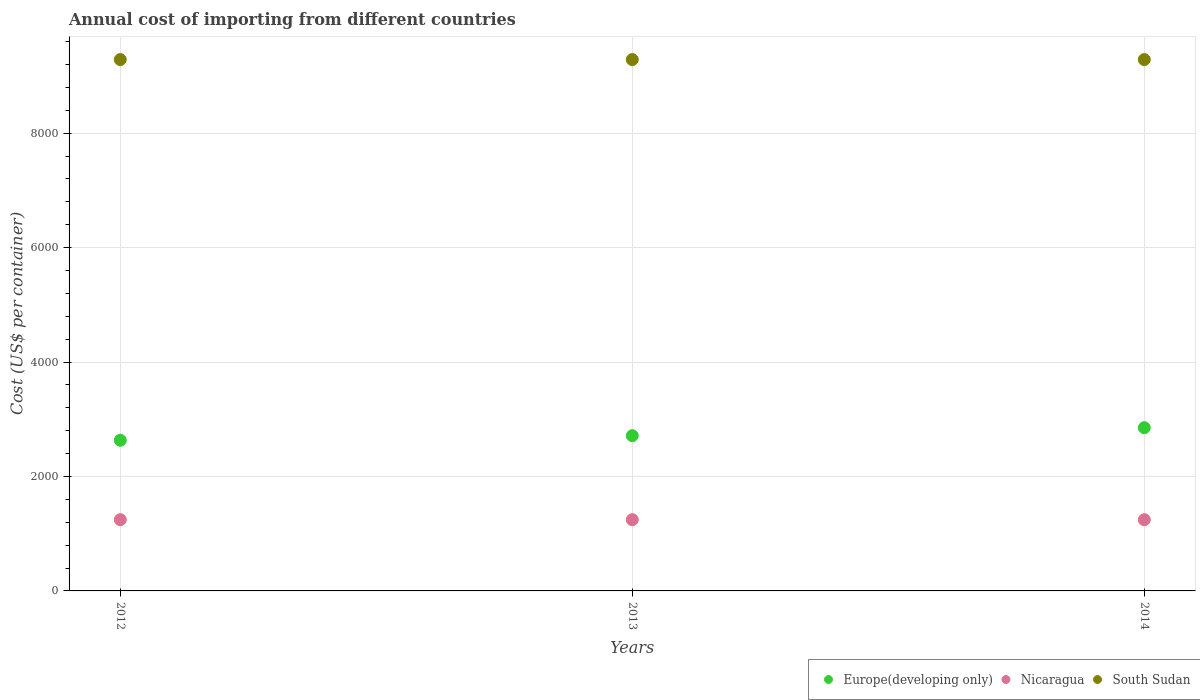How many different coloured dotlines are there?
Offer a terse response. 3. Is the number of dotlines equal to the number of legend labels?
Ensure brevity in your answer.  Yes. What is the total annual cost of importing in Europe(developing only) in 2013?
Ensure brevity in your answer.  2713. Across all years, what is the maximum total annual cost of importing in Nicaragua?
Your answer should be compact. 1245. Across all years, what is the minimum total annual cost of importing in Europe(developing only)?
Your answer should be compact. 2632.79. In which year was the total annual cost of importing in Europe(developing only) minimum?
Keep it short and to the point. 2012. What is the total total annual cost of importing in South Sudan in the graph?
Give a very brief answer. 2.79e+04. What is the difference between the total annual cost of importing in South Sudan in 2012 and that in 2014?
Give a very brief answer. 0. What is the difference between the total annual cost of importing in Nicaragua in 2013 and the total annual cost of importing in Europe(developing only) in 2012?
Offer a terse response. -1387.79. What is the average total annual cost of importing in Europe(developing only) per year?
Offer a very short reply. 2732.93. In the year 2014, what is the difference between the total annual cost of importing in South Sudan and total annual cost of importing in Nicaragua?
Offer a terse response. 8040. What is the ratio of the total annual cost of importing in Nicaragua in 2012 to that in 2013?
Your response must be concise. 1. Is the difference between the total annual cost of importing in South Sudan in 2012 and 2014 greater than the difference between the total annual cost of importing in Nicaragua in 2012 and 2014?
Make the answer very short. No. What is the difference between the highest and the second highest total annual cost of importing in Europe(developing only)?
Keep it short and to the point. 140. What is the difference between the highest and the lowest total annual cost of importing in Europe(developing only)?
Provide a succinct answer. 220.21. In how many years, is the total annual cost of importing in Nicaragua greater than the average total annual cost of importing in Nicaragua taken over all years?
Keep it short and to the point. 0. Is it the case that in every year, the sum of the total annual cost of importing in South Sudan and total annual cost of importing in Nicaragua  is greater than the total annual cost of importing in Europe(developing only)?
Make the answer very short. Yes. Does the total annual cost of importing in Europe(developing only) monotonically increase over the years?
Keep it short and to the point. Yes. Is the total annual cost of importing in Europe(developing only) strictly greater than the total annual cost of importing in South Sudan over the years?
Provide a succinct answer. No. Does the graph contain grids?
Your response must be concise. Yes. What is the title of the graph?
Offer a very short reply. Annual cost of importing from different countries. Does "South Asia" appear as one of the legend labels in the graph?
Make the answer very short. No. What is the label or title of the Y-axis?
Offer a very short reply. Cost (US$ per container). What is the Cost (US$ per container) of Europe(developing only) in 2012?
Keep it short and to the point. 2632.79. What is the Cost (US$ per container) of Nicaragua in 2012?
Ensure brevity in your answer.  1245. What is the Cost (US$ per container) of South Sudan in 2012?
Make the answer very short. 9285. What is the Cost (US$ per container) in Europe(developing only) in 2013?
Provide a succinct answer. 2713. What is the Cost (US$ per container) in Nicaragua in 2013?
Ensure brevity in your answer.  1245. What is the Cost (US$ per container) in South Sudan in 2013?
Ensure brevity in your answer.  9285. What is the Cost (US$ per container) in Europe(developing only) in 2014?
Keep it short and to the point. 2853. What is the Cost (US$ per container) in Nicaragua in 2014?
Keep it short and to the point. 1245. What is the Cost (US$ per container) of South Sudan in 2014?
Provide a short and direct response. 9285. Across all years, what is the maximum Cost (US$ per container) of Europe(developing only)?
Ensure brevity in your answer.  2853. Across all years, what is the maximum Cost (US$ per container) of Nicaragua?
Make the answer very short. 1245. Across all years, what is the maximum Cost (US$ per container) of South Sudan?
Your answer should be very brief. 9285. Across all years, what is the minimum Cost (US$ per container) of Europe(developing only)?
Provide a succinct answer. 2632.79. Across all years, what is the minimum Cost (US$ per container) in Nicaragua?
Keep it short and to the point. 1245. Across all years, what is the minimum Cost (US$ per container) in South Sudan?
Provide a succinct answer. 9285. What is the total Cost (US$ per container) in Europe(developing only) in the graph?
Give a very brief answer. 8198.79. What is the total Cost (US$ per container) in Nicaragua in the graph?
Your response must be concise. 3735. What is the total Cost (US$ per container) of South Sudan in the graph?
Give a very brief answer. 2.79e+04. What is the difference between the Cost (US$ per container) of Europe(developing only) in 2012 and that in 2013?
Your answer should be very brief. -80.21. What is the difference between the Cost (US$ per container) in Nicaragua in 2012 and that in 2013?
Your response must be concise. 0. What is the difference between the Cost (US$ per container) in Europe(developing only) in 2012 and that in 2014?
Offer a terse response. -220.21. What is the difference between the Cost (US$ per container) in Nicaragua in 2012 and that in 2014?
Provide a succinct answer. 0. What is the difference between the Cost (US$ per container) in Europe(developing only) in 2013 and that in 2014?
Provide a succinct answer. -140. What is the difference between the Cost (US$ per container) of Nicaragua in 2013 and that in 2014?
Your answer should be compact. 0. What is the difference between the Cost (US$ per container) of South Sudan in 2013 and that in 2014?
Give a very brief answer. 0. What is the difference between the Cost (US$ per container) in Europe(developing only) in 2012 and the Cost (US$ per container) in Nicaragua in 2013?
Your response must be concise. 1387.79. What is the difference between the Cost (US$ per container) of Europe(developing only) in 2012 and the Cost (US$ per container) of South Sudan in 2013?
Your answer should be compact. -6652.21. What is the difference between the Cost (US$ per container) in Nicaragua in 2012 and the Cost (US$ per container) in South Sudan in 2013?
Offer a very short reply. -8040. What is the difference between the Cost (US$ per container) of Europe(developing only) in 2012 and the Cost (US$ per container) of Nicaragua in 2014?
Keep it short and to the point. 1387.79. What is the difference between the Cost (US$ per container) of Europe(developing only) in 2012 and the Cost (US$ per container) of South Sudan in 2014?
Ensure brevity in your answer.  -6652.21. What is the difference between the Cost (US$ per container) of Nicaragua in 2012 and the Cost (US$ per container) of South Sudan in 2014?
Ensure brevity in your answer.  -8040. What is the difference between the Cost (US$ per container) in Europe(developing only) in 2013 and the Cost (US$ per container) in Nicaragua in 2014?
Your answer should be very brief. 1468. What is the difference between the Cost (US$ per container) of Europe(developing only) in 2013 and the Cost (US$ per container) of South Sudan in 2014?
Make the answer very short. -6572. What is the difference between the Cost (US$ per container) of Nicaragua in 2013 and the Cost (US$ per container) of South Sudan in 2014?
Make the answer very short. -8040. What is the average Cost (US$ per container) of Europe(developing only) per year?
Your response must be concise. 2732.93. What is the average Cost (US$ per container) of Nicaragua per year?
Provide a short and direct response. 1245. What is the average Cost (US$ per container) of South Sudan per year?
Offer a very short reply. 9285. In the year 2012, what is the difference between the Cost (US$ per container) in Europe(developing only) and Cost (US$ per container) in Nicaragua?
Your answer should be very brief. 1387.79. In the year 2012, what is the difference between the Cost (US$ per container) of Europe(developing only) and Cost (US$ per container) of South Sudan?
Provide a succinct answer. -6652.21. In the year 2012, what is the difference between the Cost (US$ per container) of Nicaragua and Cost (US$ per container) of South Sudan?
Your answer should be compact. -8040. In the year 2013, what is the difference between the Cost (US$ per container) of Europe(developing only) and Cost (US$ per container) of Nicaragua?
Your answer should be compact. 1468. In the year 2013, what is the difference between the Cost (US$ per container) of Europe(developing only) and Cost (US$ per container) of South Sudan?
Your answer should be very brief. -6572. In the year 2013, what is the difference between the Cost (US$ per container) in Nicaragua and Cost (US$ per container) in South Sudan?
Your answer should be compact. -8040. In the year 2014, what is the difference between the Cost (US$ per container) of Europe(developing only) and Cost (US$ per container) of Nicaragua?
Keep it short and to the point. 1608. In the year 2014, what is the difference between the Cost (US$ per container) of Europe(developing only) and Cost (US$ per container) of South Sudan?
Offer a terse response. -6432. In the year 2014, what is the difference between the Cost (US$ per container) of Nicaragua and Cost (US$ per container) of South Sudan?
Your answer should be very brief. -8040. What is the ratio of the Cost (US$ per container) in Europe(developing only) in 2012 to that in 2013?
Your answer should be very brief. 0.97. What is the ratio of the Cost (US$ per container) of Nicaragua in 2012 to that in 2013?
Your answer should be compact. 1. What is the ratio of the Cost (US$ per container) in Europe(developing only) in 2012 to that in 2014?
Provide a short and direct response. 0.92. What is the ratio of the Cost (US$ per container) in South Sudan in 2012 to that in 2014?
Keep it short and to the point. 1. What is the ratio of the Cost (US$ per container) of Europe(developing only) in 2013 to that in 2014?
Offer a very short reply. 0.95. What is the ratio of the Cost (US$ per container) of Nicaragua in 2013 to that in 2014?
Provide a succinct answer. 1. What is the difference between the highest and the second highest Cost (US$ per container) in Europe(developing only)?
Provide a short and direct response. 140. What is the difference between the highest and the lowest Cost (US$ per container) of Europe(developing only)?
Provide a succinct answer. 220.21. What is the difference between the highest and the lowest Cost (US$ per container) of Nicaragua?
Provide a succinct answer. 0. What is the difference between the highest and the lowest Cost (US$ per container) of South Sudan?
Provide a short and direct response. 0. 